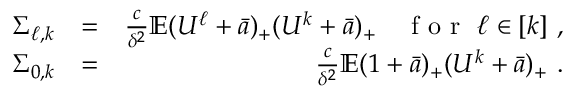<formula> <loc_0><loc_0><loc_500><loc_500>\begin{array} { r l r } { \Sigma _ { \ell , k } } & { = } & { \frac { c } \delta ^ { 2 } } \mathbb { E } ( U ^ { \ell } + \bar { a } ) _ { + } ( U ^ { k } + \bar { a } ) _ { + } \quad f o r \ \ell \in [ k ] \ , } \\ { \Sigma _ { 0 , k } } & { = } & { \frac { c } \delta ^ { 2 } } \mathbb { E } ( 1 + \bar { a } ) _ { + } ( U ^ { k } + \bar { a } ) _ { + } \ . } \end{array}</formula> 